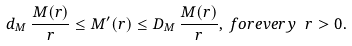Convert formula to latex. <formula><loc_0><loc_0><loc_500><loc_500>d _ { M } \, \frac { M ( r ) } { r } \leq M ^ { \prime } ( r ) \leq D _ { M } \, \frac { M ( r ) } { r } , \, f o r e v e r y \ r > 0 .</formula> 